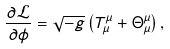Convert formula to latex. <formula><loc_0><loc_0><loc_500><loc_500>\frac { \partial \mathcal { L } } { \partial \phi } = \sqrt { - g } \left ( T ^ { \mu } _ { \mu } + \Theta ^ { \mu } _ { \mu } \right ) ,</formula> 